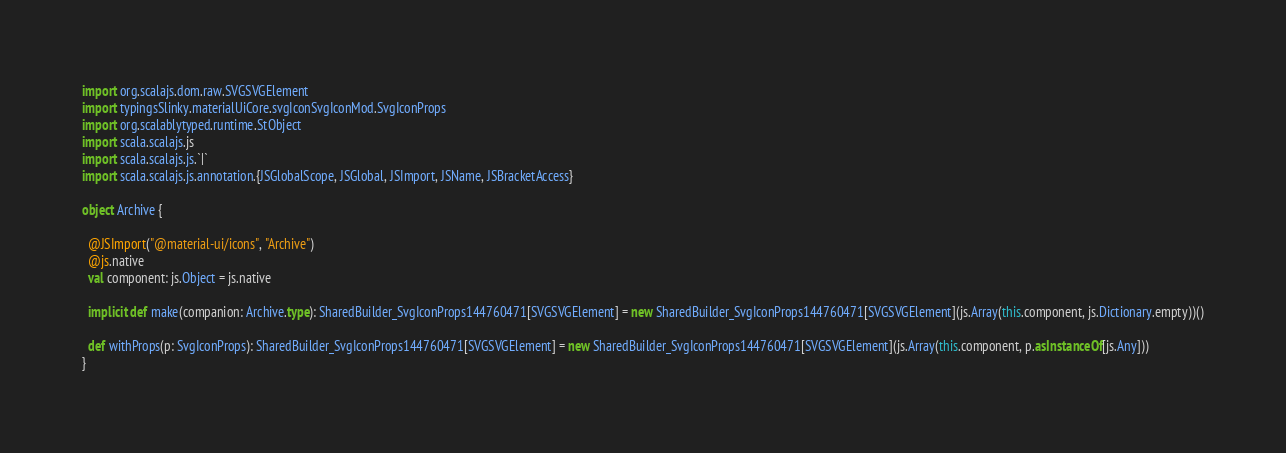<code> <loc_0><loc_0><loc_500><loc_500><_Scala_>
import org.scalajs.dom.raw.SVGSVGElement
import typingsSlinky.materialUiCore.svgIconSvgIconMod.SvgIconProps
import org.scalablytyped.runtime.StObject
import scala.scalajs.js
import scala.scalajs.js.`|`
import scala.scalajs.js.annotation.{JSGlobalScope, JSGlobal, JSImport, JSName, JSBracketAccess}

object Archive {
  
  @JSImport("@material-ui/icons", "Archive")
  @js.native
  val component: js.Object = js.native
  
  implicit def make(companion: Archive.type): SharedBuilder_SvgIconProps144760471[SVGSVGElement] = new SharedBuilder_SvgIconProps144760471[SVGSVGElement](js.Array(this.component, js.Dictionary.empty))()
  
  def withProps(p: SvgIconProps): SharedBuilder_SvgIconProps144760471[SVGSVGElement] = new SharedBuilder_SvgIconProps144760471[SVGSVGElement](js.Array(this.component, p.asInstanceOf[js.Any]))
}
</code> 